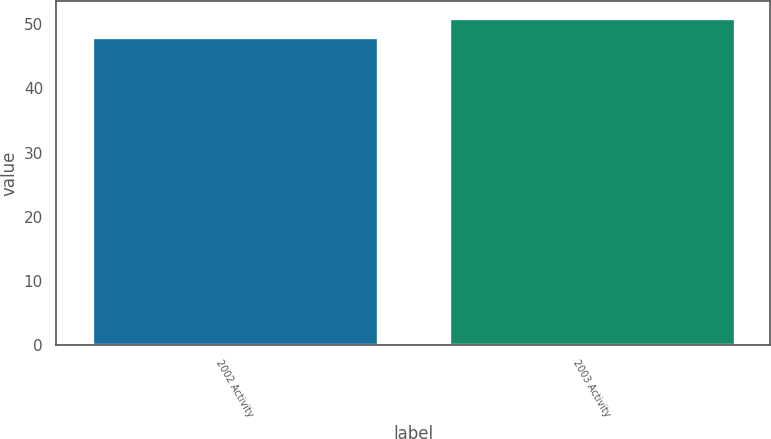Convert chart. <chart><loc_0><loc_0><loc_500><loc_500><bar_chart><fcel>2002 Activity<fcel>2003 Activity<nl><fcel>48<fcel>51<nl></chart> 